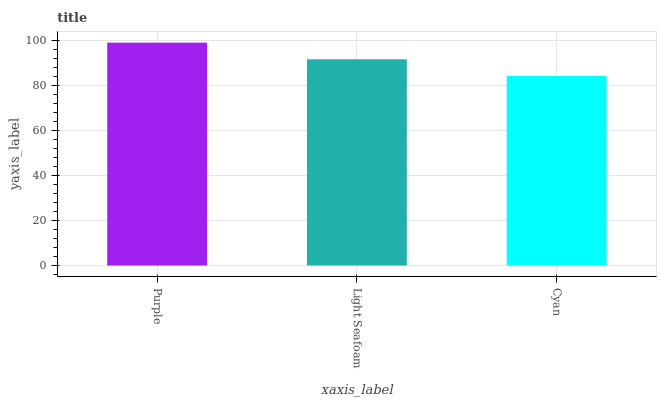Is Cyan the minimum?
Answer yes or no. Yes. Is Purple the maximum?
Answer yes or no. Yes. Is Light Seafoam the minimum?
Answer yes or no. No. Is Light Seafoam the maximum?
Answer yes or no. No. Is Purple greater than Light Seafoam?
Answer yes or no. Yes. Is Light Seafoam less than Purple?
Answer yes or no. Yes. Is Light Seafoam greater than Purple?
Answer yes or no. No. Is Purple less than Light Seafoam?
Answer yes or no. No. Is Light Seafoam the high median?
Answer yes or no. Yes. Is Light Seafoam the low median?
Answer yes or no. Yes. Is Purple the high median?
Answer yes or no. No. Is Purple the low median?
Answer yes or no. No. 